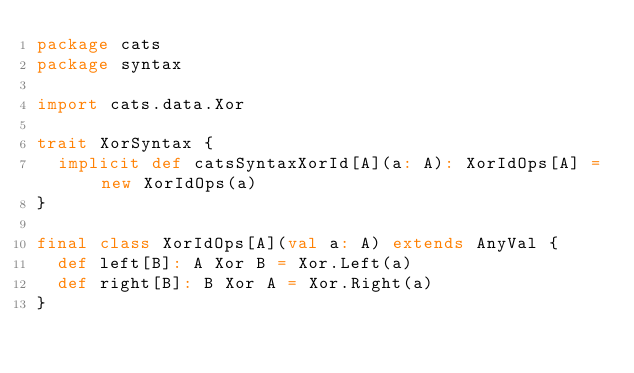<code> <loc_0><loc_0><loc_500><loc_500><_Scala_>package cats
package syntax

import cats.data.Xor

trait XorSyntax {
  implicit def catsSyntaxXorId[A](a: A): XorIdOps[A] = new XorIdOps(a)
}

final class XorIdOps[A](val a: A) extends AnyVal {
  def left[B]: A Xor B = Xor.Left(a)
  def right[B]: B Xor A = Xor.Right(a)
}
</code> 